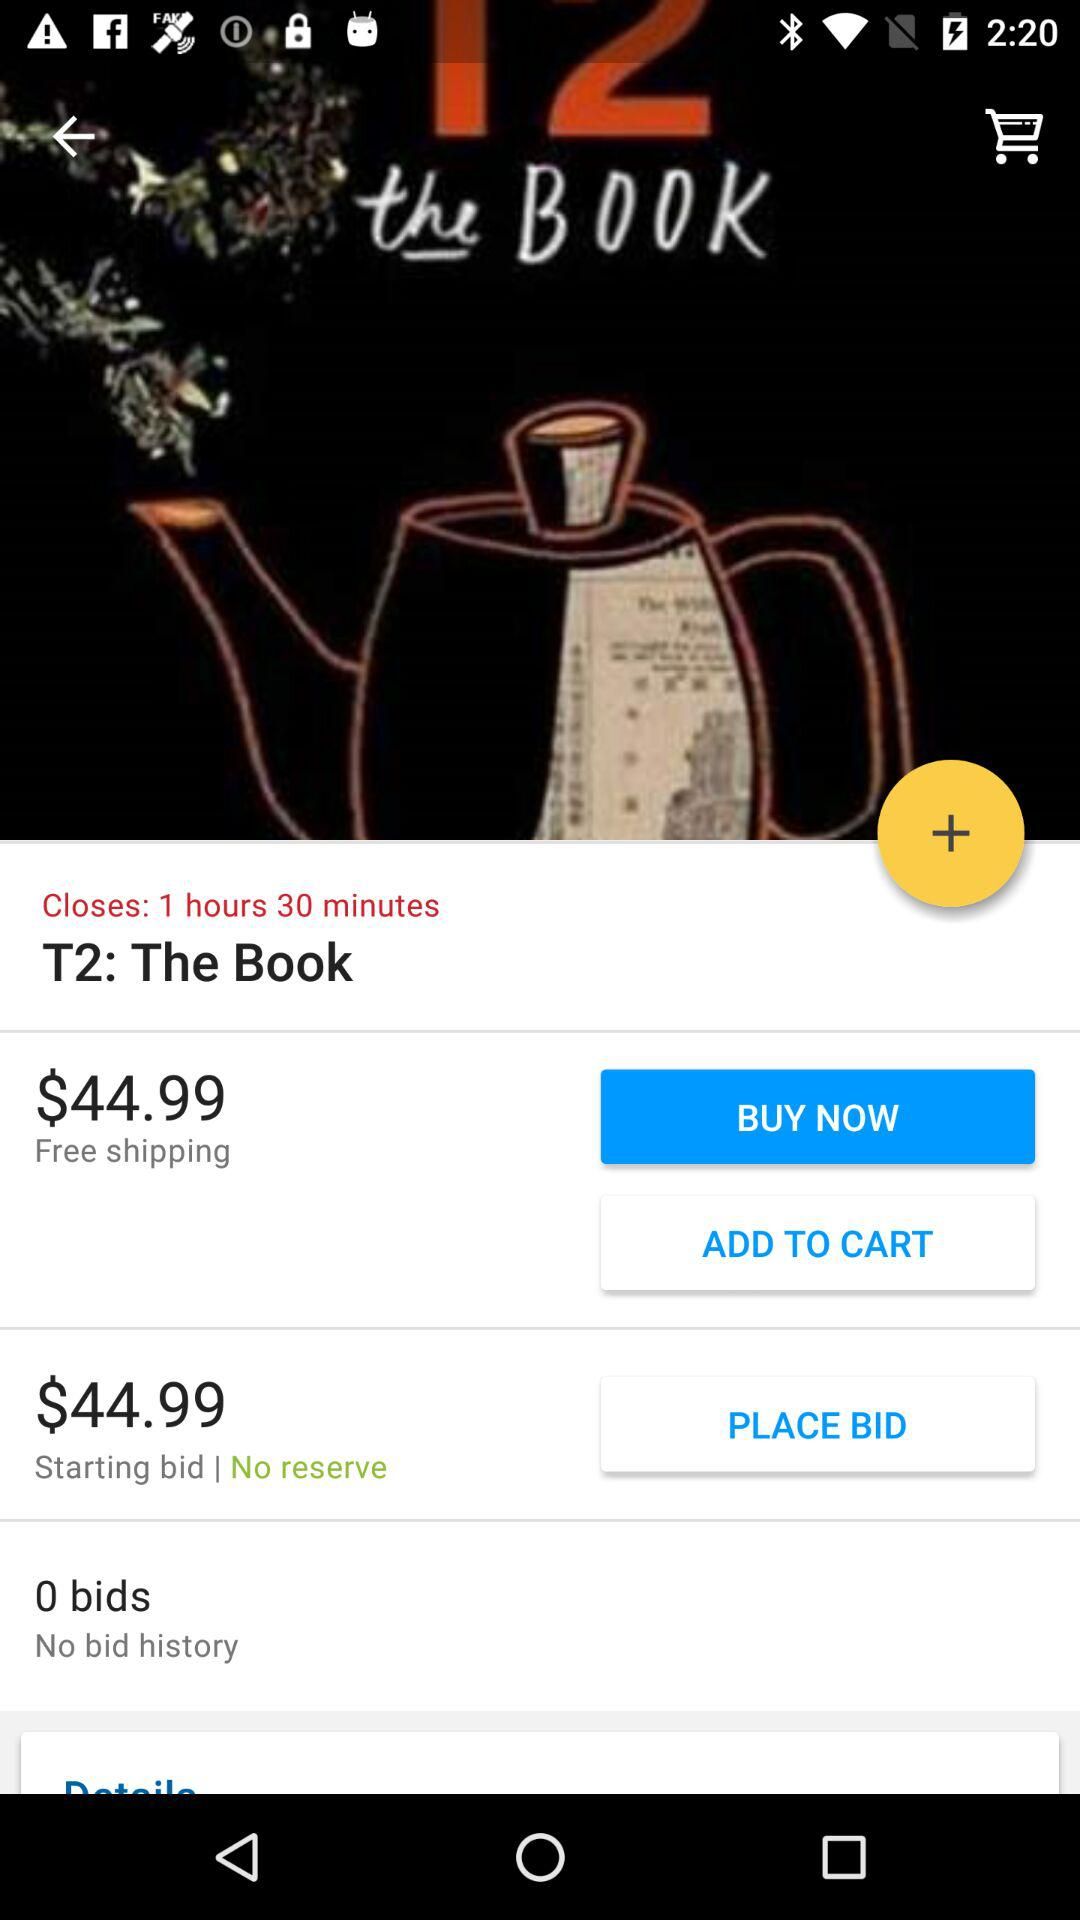Are there any bids? There are 0 bids. 